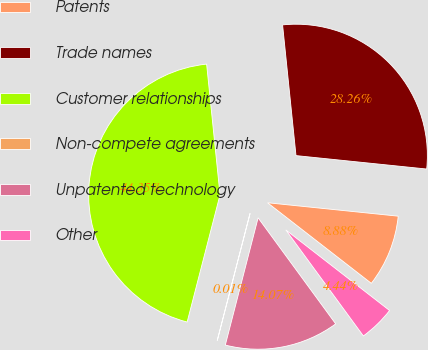Convert chart. <chart><loc_0><loc_0><loc_500><loc_500><pie_chart><fcel>Patents<fcel>Trade names<fcel>Customer relationships<fcel>Non-compete agreements<fcel>Unpatented technology<fcel>Other<nl><fcel>8.88%<fcel>28.26%<fcel>44.35%<fcel>0.01%<fcel>14.07%<fcel>4.44%<nl></chart> 